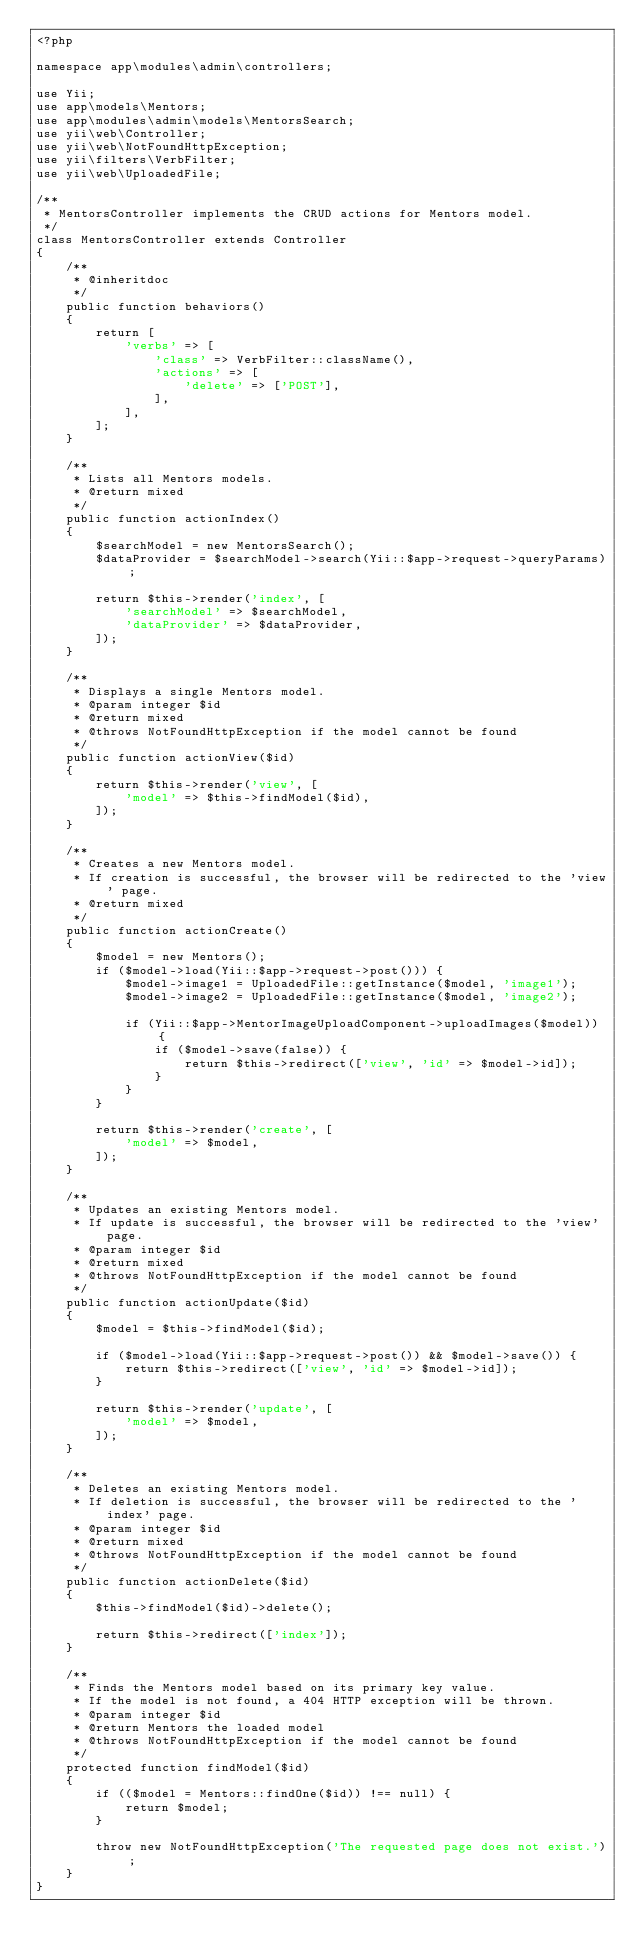Convert code to text. <code><loc_0><loc_0><loc_500><loc_500><_PHP_><?php

namespace app\modules\admin\controllers;

use Yii;
use app\models\Mentors;
use app\modules\admin\models\MentorsSearch;
use yii\web\Controller;
use yii\web\NotFoundHttpException;
use yii\filters\VerbFilter;
use yii\web\UploadedFile;

/**
 * MentorsController implements the CRUD actions for Mentors model.
 */
class MentorsController extends Controller
{
    /**
     * @inheritdoc
     */
    public function behaviors()
    {
        return [
            'verbs' => [
                'class' => VerbFilter::className(),
                'actions' => [
                    'delete' => ['POST'],
                ],
            ],
        ];
    }

    /**
     * Lists all Mentors models.
     * @return mixed
     */
    public function actionIndex()
    {
        $searchModel = new MentorsSearch();
        $dataProvider = $searchModel->search(Yii::$app->request->queryParams);

        return $this->render('index', [
            'searchModel' => $searchModel,
            'dataProvider' => $dataProvider,
        ]);
    }

    /**
     * Displays a single Mentors model.
     * @param integer $id
     * @return mixed
     * @throws NotFoundHttpException if the model cannot be found
     */
    public function actionView($id)
    {
        return $this->render('view', [
            'model' => $this->findModel($id),
        ]);
    }

    /**
     * Creates a new Mentors model.
     * If creation is successful, the browser will be redirected to the 'view' page.
     * @return mixed
     */
    public function actionCreate()
    {
        $model = new Mentors();
        if ($model->load(Yii::$app->request->post())) {
            $model->image1 = UploadedFile::getInstance($model, 'image1');
            $model->image2 = UploadedFile::getInstance($model, 'image2');
            
            if (Yii::$app->MentorImageUploadComponent->uploadImages($model)) {
                if ($model->save(false)) {
                    return $this->redirect(['view', 'id' => $model->id]);
                }
            }
        }

        return $this->render('create', [
            'model' => $model,
        ]);
    }

    /**
     * Updates an existing Mentors model.
     * If update is successful, the browser will be redirected to the 'view' page.
     * @param integer $id
     * @return mixed
     * @throws NotFoundHttpException if the model cannot be found
     */
    public function actionUpdate($id)
    {
        $model = $this->findModel($id);

        if ($model->load(Yii::$app->request->post()) && $model->save()) {
            return $this->redirect(['view', 'id' => $model->id]);
        }

        return $this->render('update', [
            'model' => $model,
        ]);
    }

    /**
     * Deletes an existing Mentors model.
     * If deletion is successful, the browser will be redirected to the 'index' page.
     * @param integer $id
     * @return mixed
     * @throws NotFoundHttpException if the model cannot be found
     */
    public function actionDelete($id)
    {
        $this->findModel($id)->delete();

        return $this->redirect(['index']);
    }

    /**
     * Finds the Mentors model based on its primary key value.
     * If the model is not found, a 404 HTTP exception will be thrown.
     * @param integer $id
     * @return Mentors the loaded model
     * @throws NotFoundHttpException if the model cannot be found
     */
    protected function findModel($id)
    {
        if (($model = Mentors::findOne($id)) !== null) {
            return $model;
        }

        throw new NotFoundHttpException('The requested page does not exist.');
    }
}
</code> 